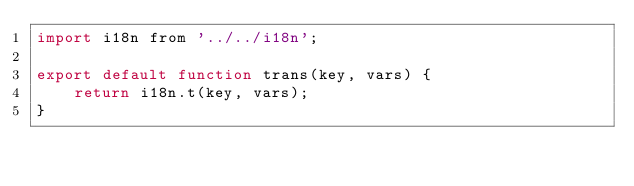Convert code to text. <code><loc_0><loc_0><loc_500><loc_500><_JavaScript_>import i18n from '../../i18n';

export default function trans(key, vars) {
    return i18n.t(key, vars);
}
</code> 